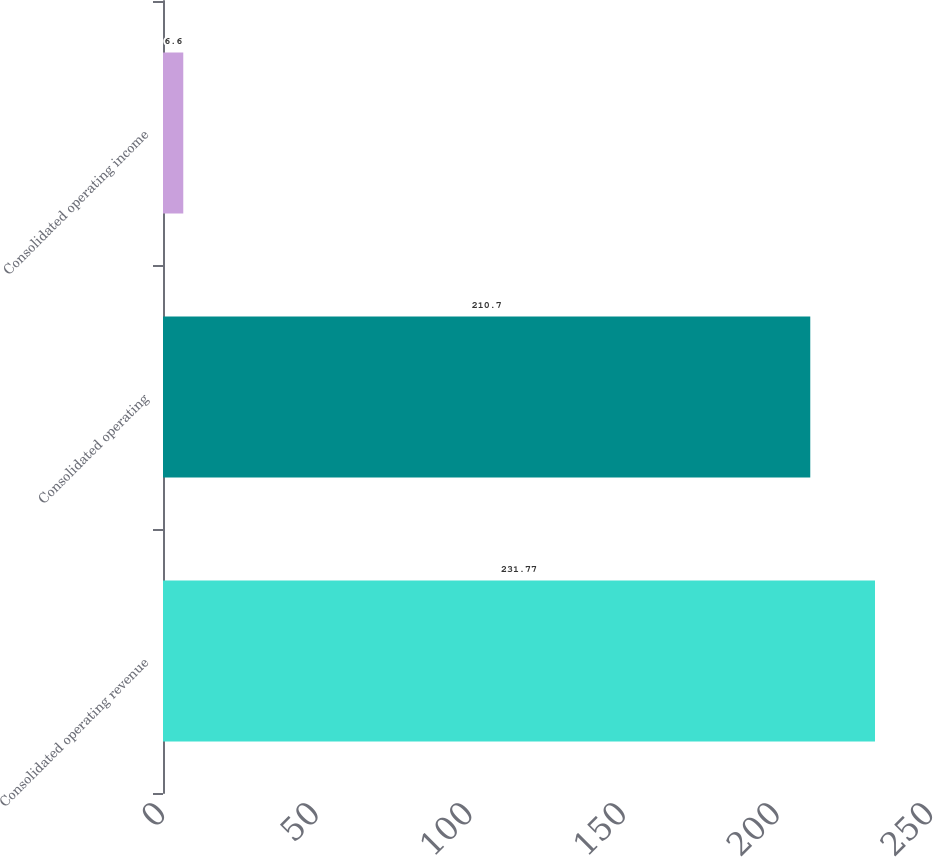Convert chart. <chart><loc_0><loc_0><loc_500><loc_500><bar_chart><fcel>Consolidated operating revenue<fcel>Consolidated operating<fcel>Consolidated operating income<nl><fcel>231.77<fcel>210.7<fcel>6.6<nl></chart> 